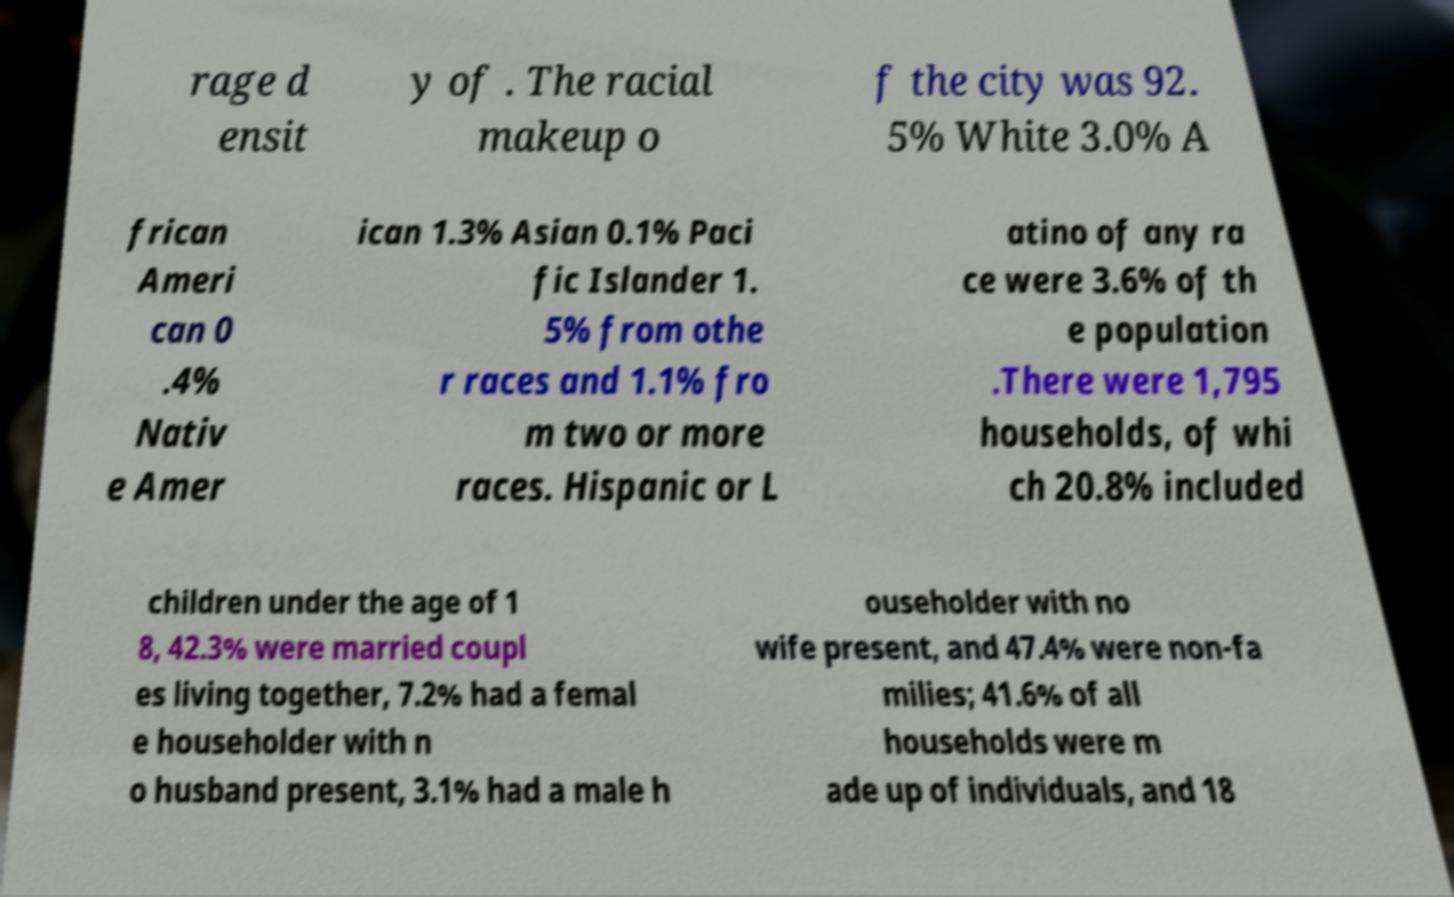I need the written content from this picture converted into text. Can you do that? rage d ensit y of . The racial makeup o f the city was 92. 5% White 3.0% A frican Ameri can 0 .4% Nativ e Amer ican 1.3% Asian 0.1% Paci fic Islander 1. 5% from othe r races and 1.1% fro m two or more races. Hispanic or L atino of any ra ce were 3.6% of th e population .There were 1,795 households, of whi ch 20.8% included children under the age of 1 8, 42.3% were married coupl es living together, 7.2% had a femal e householder with n o husband present, 3.1% had a male h ouseholder with no wife present, and 47.4% were non-fa milies; 41.6% of all households were m ade up of individuals, and 18 